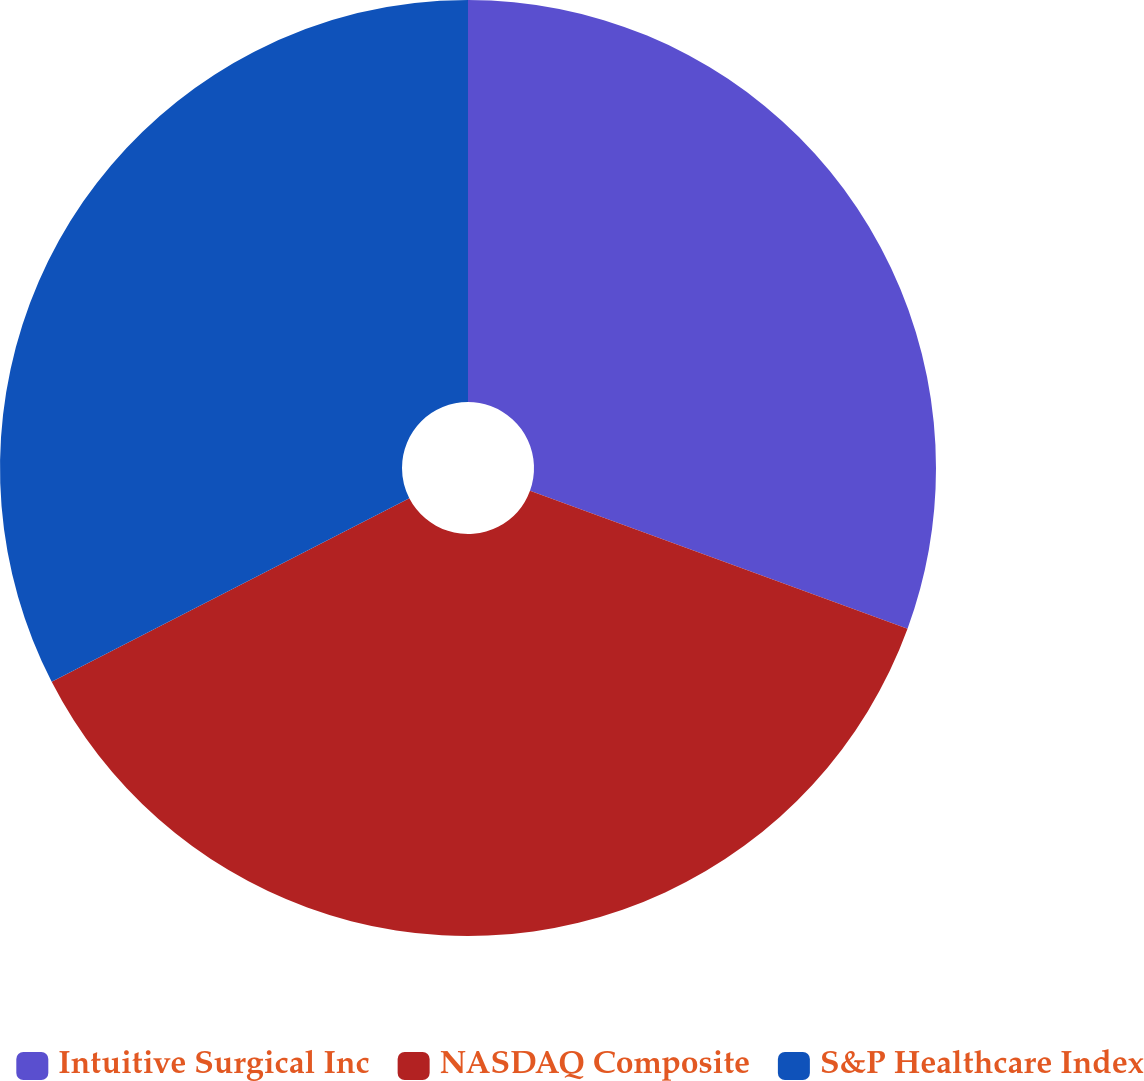<chart> <loc_0><loc_0><loc_500><loc_500><pie_chart><fcel>Intuitive Surgical Inc<fcel>NASDAQ Composite<fcel>S&P Healthcare Index<nl><fcel>30.58%<fcel>36.87%<fcel>32.55%<nl></chart> 